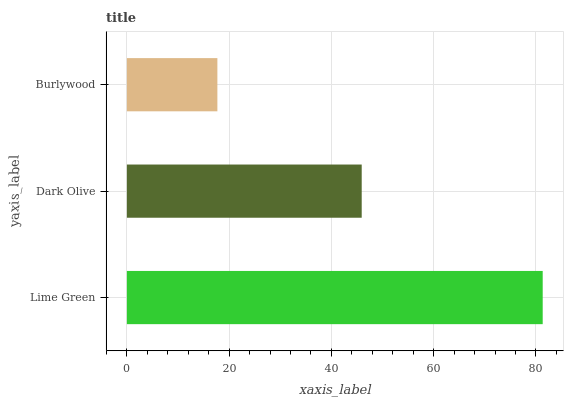Is Burlywood the minimum?
Answer yes or no. Yes. Is Lime Green the maximum?
Answer yes or no. Yes. Is Dark Olive the minimum?
Answer yes or no. No. Is Dark Olive the maximum?
Answer yes or no. No. Is Lime Green greater than Dark Olive?
Answer yes or no. Yes. Is Dark Olive less than Lime Green?
Answer yes or no. Yes. Is Dark Olive greater than Lime Green?
Answer yes or no. No. Is Lime Green less than Dark Olive?
Answer yes or no. No. Is Dark Olive the high median?
Answer yes or no. Yes. Is Dark Olive the low median?
Answer yes or no. Yes. Is Burlywood the high median?
Answer yes or no. No. Is Burlywood the low median?
Answer yes or no. No. 